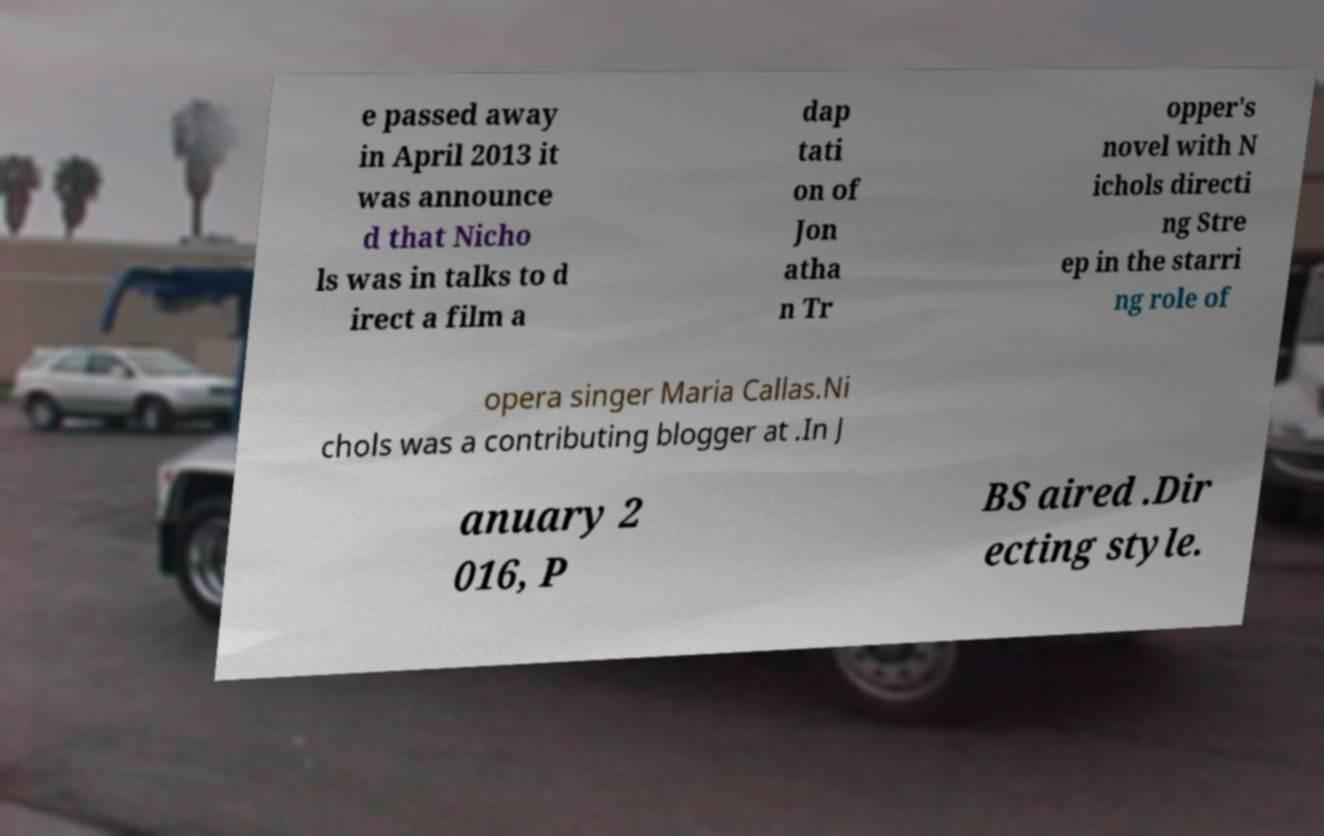Can you accurately transcribe the text from the provided image for me? e passed away in April 2013 it was announce d that Nicho ls was in talks to d irect a film a dap tati on of Jon atha n Tr opper's novel with N ichols directi ng Stre ep in the starri ng role of opera singer Maria Callas.Ni chols was a contributing blogger at .In J anuary 2 016, P BS aired .Dir ecting style. 